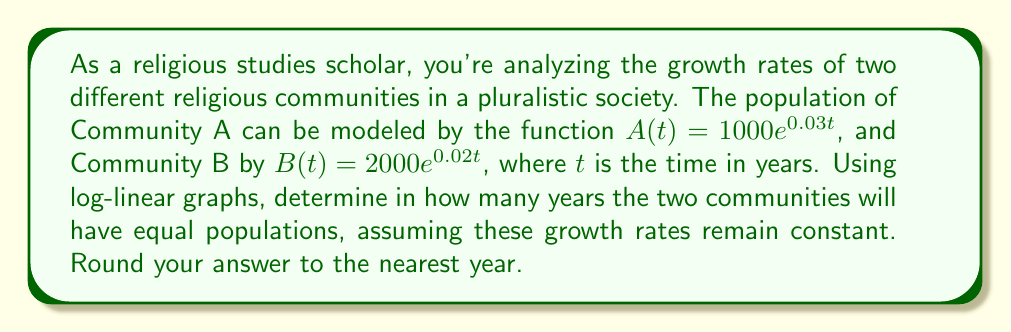Show me your answer to this math problem. To solve this problem, we'll use the properties of logarithms and exponential functions:

1) First, we set the two population functions equal to each other:

   $1000e^{0.03t} = 2000e^{0.02t}$

2) We can simplify this by dividing both sides by 1000:

   $e^{0.03t} = 2e^{0.02t}$

3) Now, we take the natural logarithm of both sides:

   $\ln(e^{0.03t}) = \ln(2e^{0.02t})$

4) Using the properties of logarithms:

   $0.03t = \ln(2) + 0.02t$

5) Subtract 0.02t from both sides:

   $0.01t = \ln(2)$

6) Divide both sides by 0.01:

   $t = \frac{\ln(2)}{0.01}$

7) Calculate this value:

   $t \approx 69.3147$ years

8) Rounding to the nearest year:

   $t \approx 69$ years

This approach using logarithms allows us to compare exponential growth rates on a linear scale, which is particularly useful in analyzing religious demographic changes over time.
Answer: 69 years 